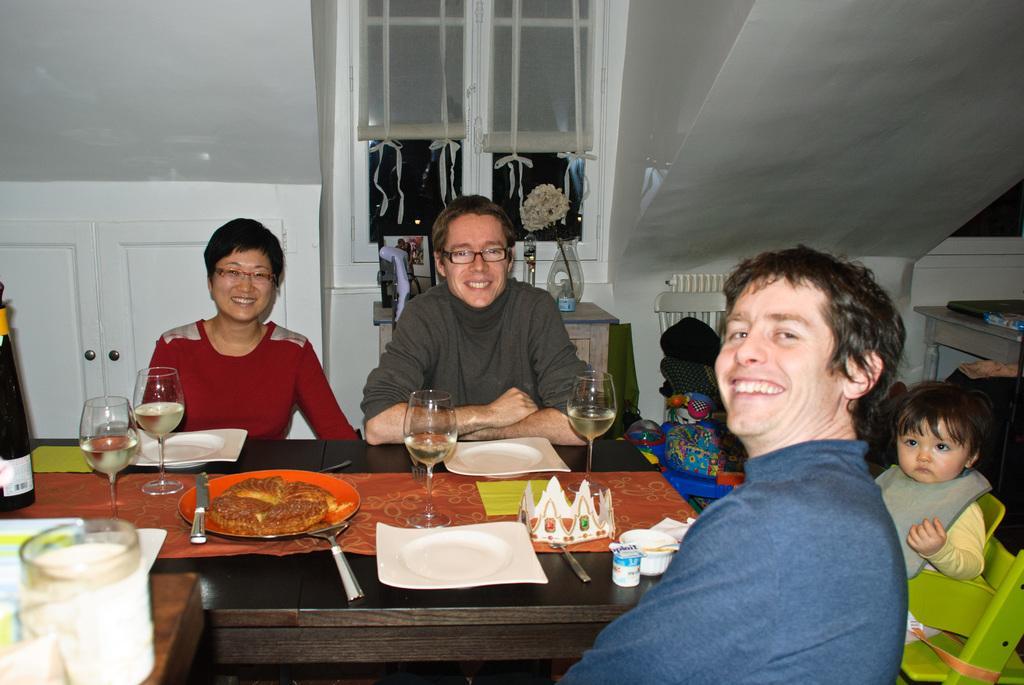Could you give a brief overview of what you see in this image? In this picture we can see three people and one child sitting in front of a table, we can see four glasses of drinks on the table and two plates and we can also see one knife and one spoon, there is food present in the table, in the background we can see a window and curtains, on the right side of the image there is a table, on the left side of the image we can see one cupboard. 